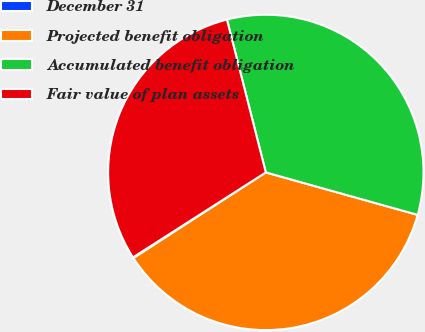<chart> <loc_0><loc_0><loc_500><loc_500><pie_chart><fcel>December 31<fcel>Projected benefit obligation<fcel>Accumulated benefit obligation<fcel>Fair value of plan assets<nl><fcel>0.09%<fcel>36.51%<fcel>33.3%<fcel>30.09%<nl></chart> 